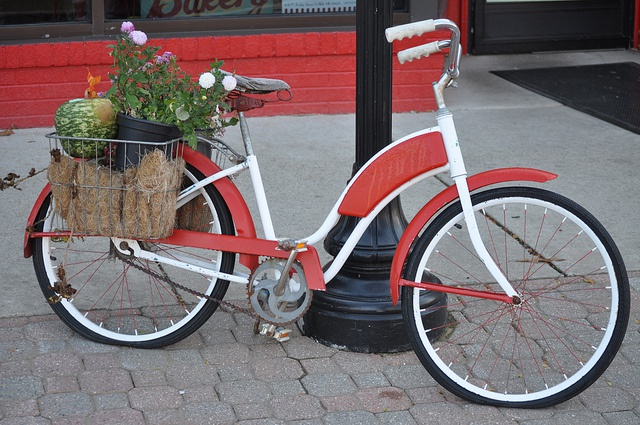Describe the objects in this image and their specific colors. I can see bicycle in black, darkgray, gray, and lightgray tones and potted plant in black, gray, and darkgreen tones in this image. 